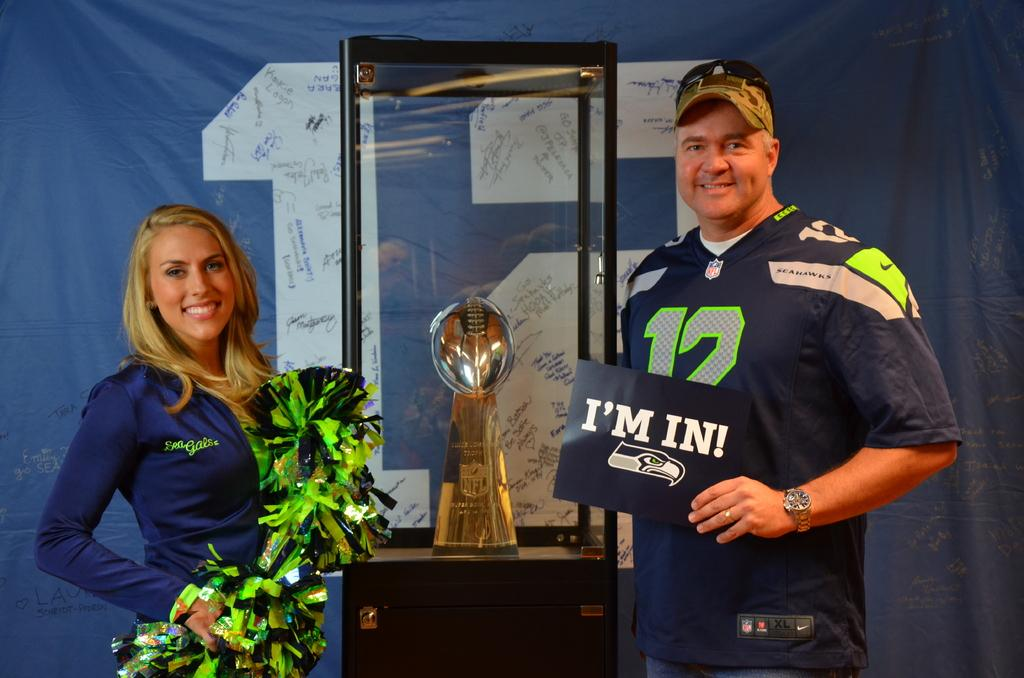<image>
Share a concise interpretation of the image provided. a man that is holding a sign that says I'm in 